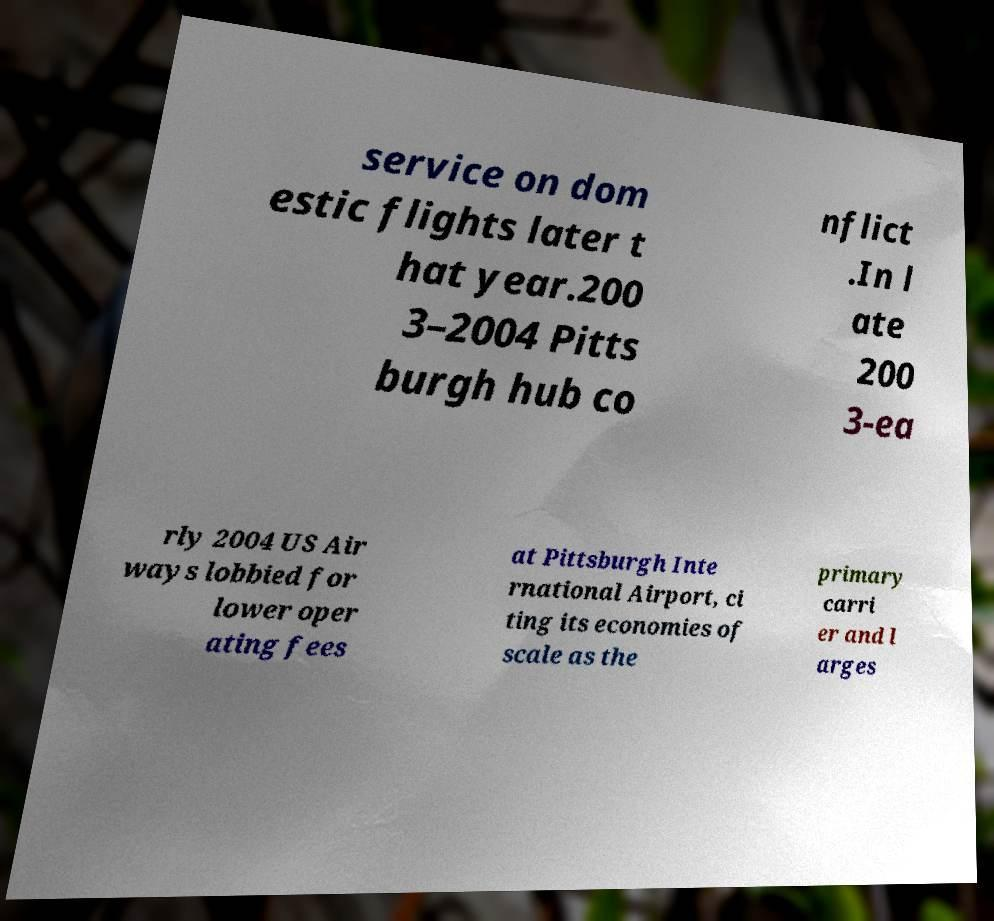Could you assist in decoding the text presented in this image and type it out clearly? service on dom estic flights later t hat year.200 3–2004 Pitts burgh hub co nflict .In l ate 200 3-ea rly 2004 US Air ways lobbied for lower oper ating fees at Pittsburgh Inte rnational Airport, ci ting its economies of scale as the primary carri er and l arges 